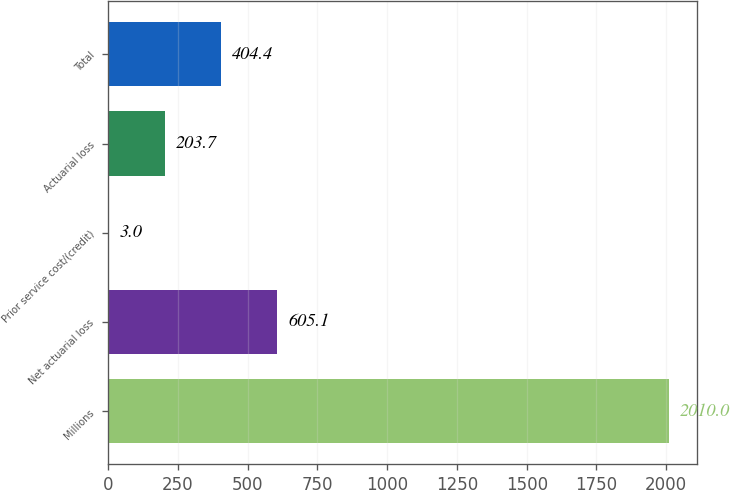Convert chart. <chart><loc_0><loc_0><loc_500><loc_500><bar_chart><fcel>Millions<fcel>Net actuarial loss<fcel>Prior service cost/(credit)<fcel>Actuarial loss<fcel>Total<nl><fcel>2010<fcel>605.1<fcel>3<fcel>203.7<fcel>404.4<nl></chart> 